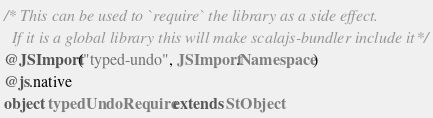<code> <loc_0><loc_0><loc_500><loc_500><_Scala_>/* This can be used to `require` the library as a side effect.
  If it is a global library this will make scalajs-bundler include it */
@JSImport("typed-undo", JSImport.Namespace)
@js.native
object typedUndoRequire extends StObject
</code> 